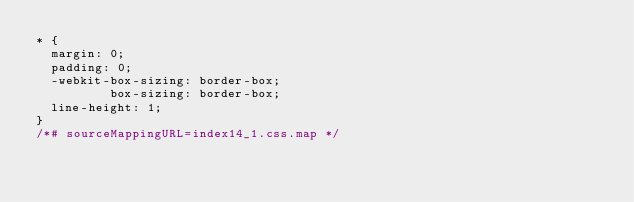<code> <loc_0><loc_0><loc_500><loc_500><_CSS_>* {
  margin: 0;
  padding: 0;
  -webkit-box-sizing: border-box;
          box-sizing: border-box;
  line-height: 1;
}
/*# sourceMappingURL=index14_1.css.map */</code> 